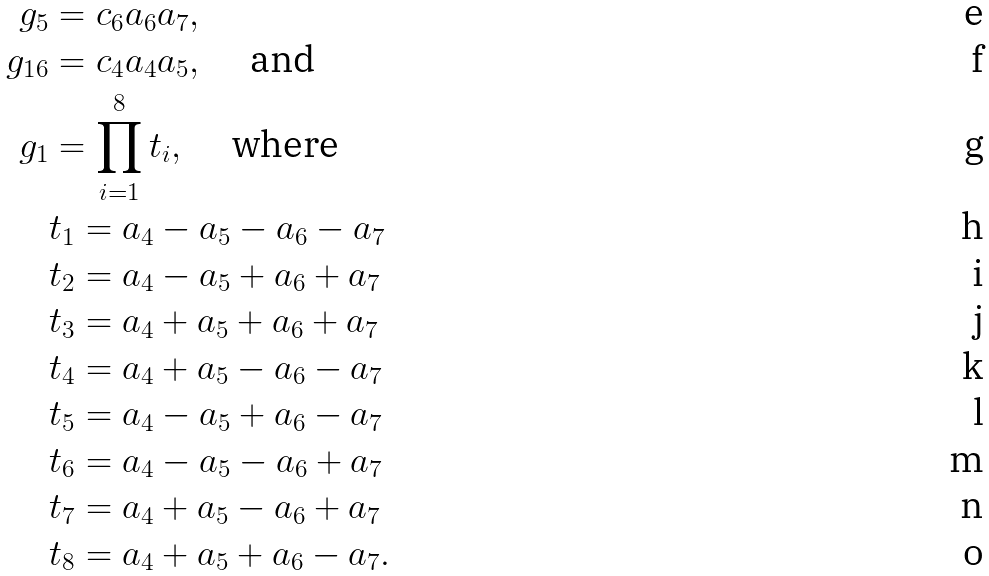Convert formula to latex. <formula><loc_0><loc_0><loc_500><loc_500>g _ { 5 } & = c _ { 6 } a _ { 6 } a _ { 7 } , \\ g _ { 1 6 } & = c _ { 4 } a _ { 4 } a _ { 5 } , \quad \text { and} \\ g _ { 1 } & = \prod _ { i = 1 } ^ { 8 } t _ { i } , \quad \text { where} \\ & t _ { 1 } = a _ { 4 } - a _ { 5 } - a _ { 6 } - a _ { 7 } \\ & t _ { 2 } = a _ { 4 } - a _ { 5 } + a _ { 6 } + a _ { 7 } \\ & t _ { 3 } = a _ { 4 } + a _ { 5 } + a _ { 6 } + a _ { 7 } \\ & t _ { 4 } = a _ { 4 } + a _ { 5 } - a _ { 6 } - a _ { 7 } \\ & t _ { 5 } = a _ { 4 } - a _ { 5 } + a _ { 6 } - a _ { 7 } \\ & t _ { 6 } = a _ { 4 } - a _ { 5 } - a _ { 6 } + a _ { 7 } \\ & t _ { 7 } = a _ { 4 } + a _ { 5 } - a _ { 6 } + a _ { 7 } \\ & t _ { 8 } = a _ { 4 } + a _ { 5 } + a _ { 6 } - a _ { 7 } .</formula> 